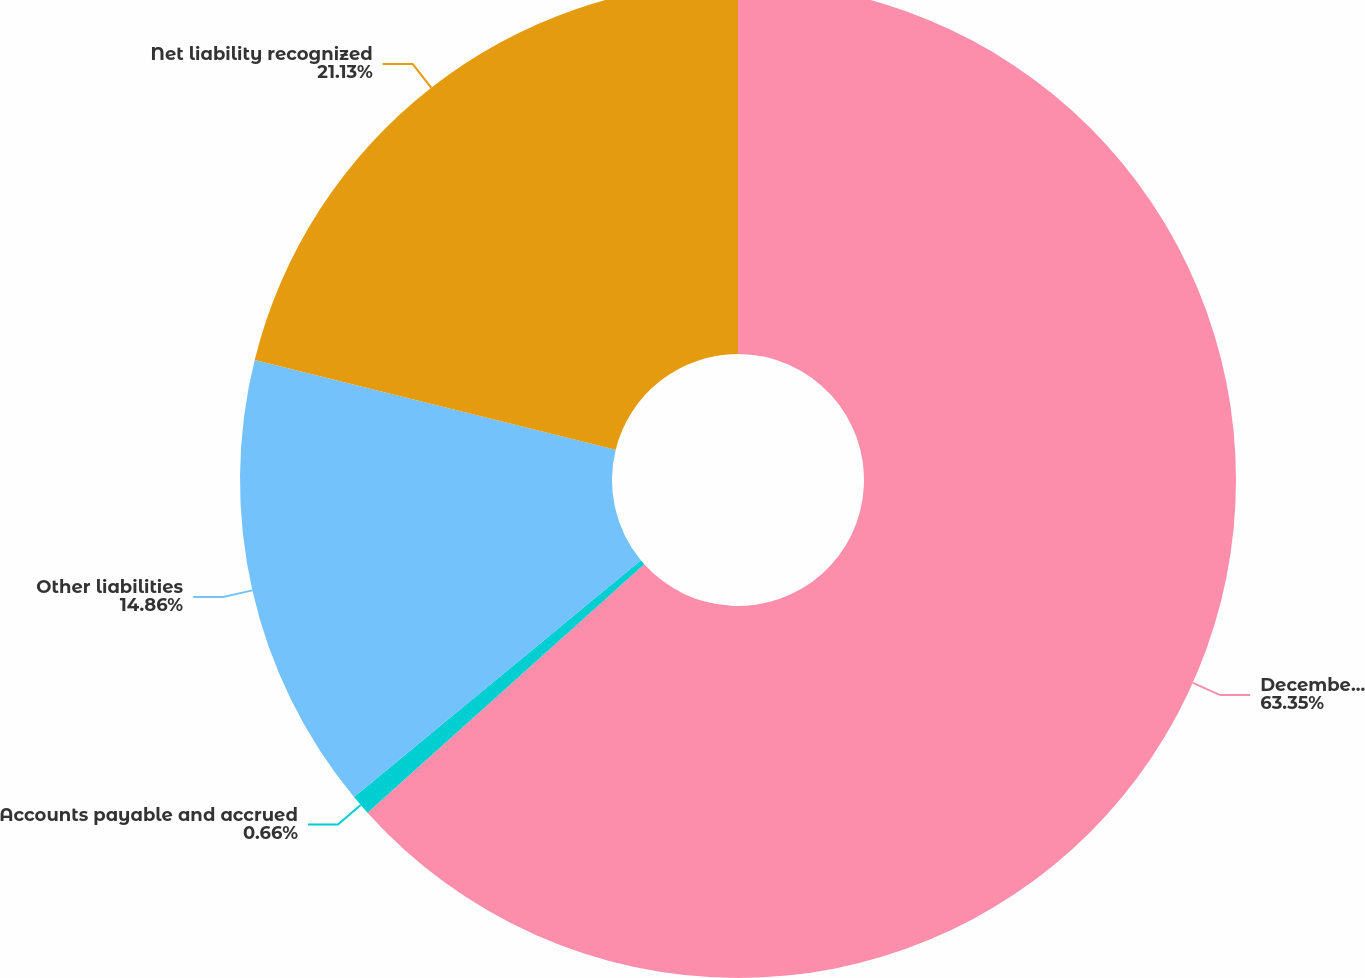<chart> <loc_0><loc_0><loc_500><loc_500><pie_chart><fcel>December 31<fcel>Accounts payable and accrued<fcel>Other liabilities<fcel>Net liability recognized<nl><fcel>63.36%<fcel>0.66%<fcel>14.86%<fcel>21.13%<nl></chart> 